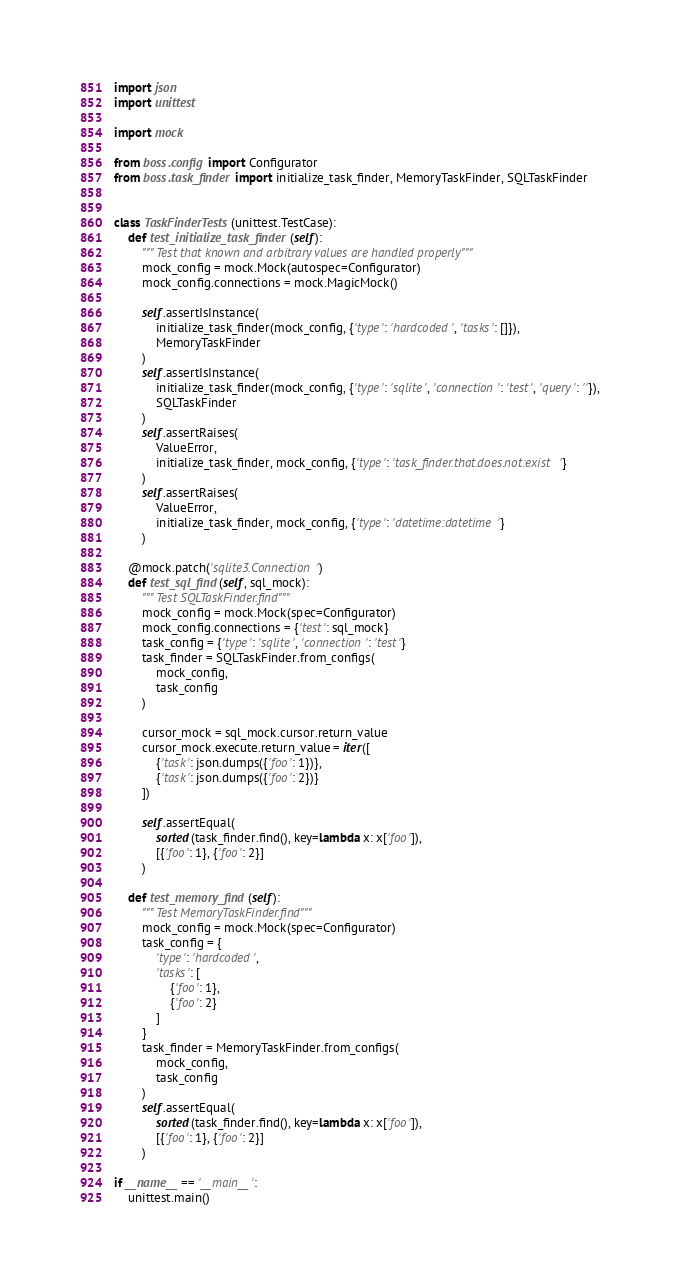<code> <loc_0><loc_0><loc_500><loc_500><_Python_>import json
import unittest

import mock

from boss.config import Configurator
from boss.task_finder import initialize_task_finder, MemoryTaskFinder, SQLTaskFinder


class TaskFinderTests(unittest.TestCase):
    def test_initialize_task_finder(self):
        """ Test that known and arbitrary values are handled properly"""
        mock_config = mock.Mock(autospec=Configurator)
        mock_config.connections = mock.MagicMock()

        self.assertIsInstance(
            initialize_task_finder(mock_config, {'type': 'hardcoded', 'tasks': []}),
            MemoryTaskFinder
        )
        self.assertIsInstance(
            initialize_task_finder(mock_config, {'type': 'sqlite', 'connection': 'test', 'query': ''}),
            SQLTaskFinder
        )
        self.assertRaises(
            ValueError,
            initialize_task_finder, mock_config, {'type': 'task_finder.that.does.not:exist'}
        )
        self.assertRaises(
            ValueError,
            initialize_task_finder, mock_config, {'type': 'datetime:datetime'}
        )

    @mock.patch('sqlite3.Connection')
    def test_sql_find(self, sql_mock):
        """ Test SQLTaskFinder.find"""
        mock_config = mock.Mock(spec=Configurator)
        mock_config.connections = {'test': sql_mock}
        task_config = {'type': 'sqlite', 'connection': 'test'}
        task_finder = SQLTaskFinder.from_configs(
            mock_config,
            task_config
        )

        cursor_mock = sql_mock.cursor.return_value
        cursor_mock.execute.return_value = iter([
            {'task': json.dumps({'foo': 1})},
            {'task': json.dumps({'foo': 2})}
        ])

        self.assertEqual(
            sorted(task_finder.find(), key=lambda x: x['foo']),
            [{'foo': 1}, {'foo': 2}]
        )

    def test_memory_find(self):
        """ Test MemoryTaskFinder.find"""
        mock_config = mock.Mock(spec=Configurator)
        task_config = {
            'type': 'hardcoded',
            'tasks': [
                {'foo': 1},
                {'foo': 2}
            ]
        }
        task_finder = MemoryTaskFinder.from_configs(
            mock_config,
            task_config
        )
        self.assertEqual(
            sorted(task_finder.find(), key=lambda x: x['foo']),
            [{'foo': 1}, {'foo': 2}]
        )

if __name__ == '__main__':
    unittest.main()
</code> 